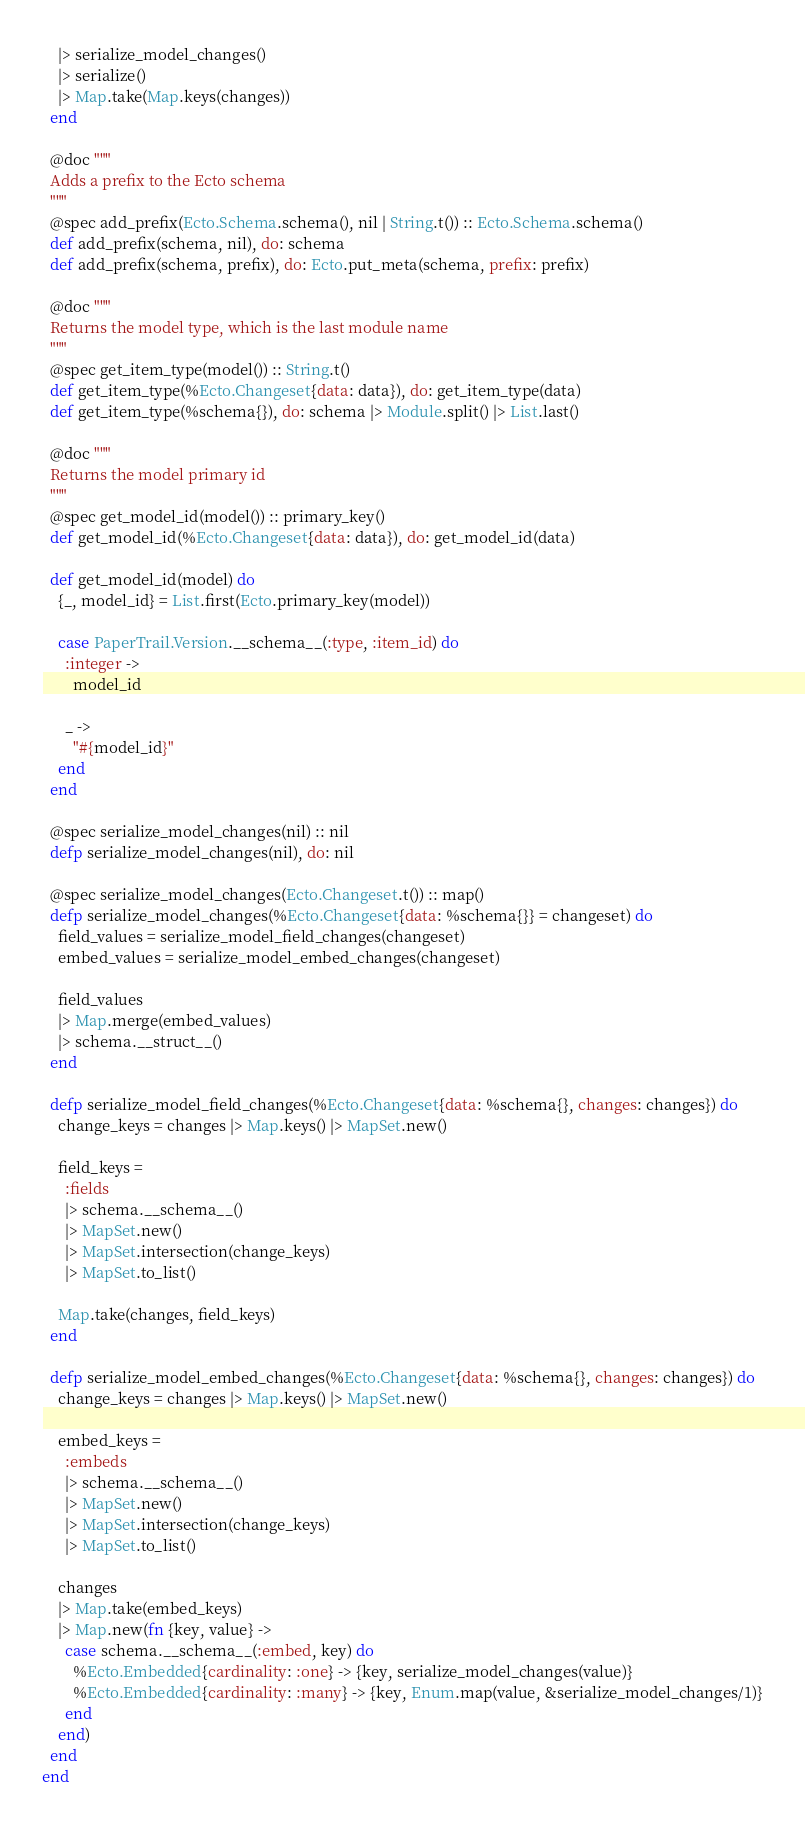Convert code to text. <code><loc_0><loc_0><loc_500><loc_500><_Elixir_>    |> serialize_model_changes()
    |> serialize()
    |> Map.take(Map.keys(changes))
  end

  @doc """
  Adds a prefix to the Ecto schema
  """
  @spec add_prefix(Ecto.Schema.schema(), nil | String.t()) :: Ecto.Schema.schema()
  def add_prefix(schema, nil), do: schema
  def add_prefix(schema, prefix), do: Ecto.put_meta(schema, prefix: prefix)

  @doc """
  Returns the model type, which is the last module name
  """
  @spec get_item_type(model()) :: String.t()
  def get_item_type(%Ecto.Changeset{data: data}), do: get_item_type(data)
  def get_item_type(%schema{}), do: schema |> Module.split() |> List.last()

  @doc """
  Returns the model primary id
  """
  @spec get_model_id(model()) :: primary_key()
  def get_model_id(%Ecto.Changeset{data: data}), do: get_model_id(data)

  def get_model_id(model) do
    {_, model_id} = List.first(Ecto.primary_key(model))

    case PaperTrail.Version.__schema__(:type, :item_id) do
      :integer ->
        model_id

      _ ->
        "#{model_id}"
    end
  end

  @spec serialize_model_changes(nil) :: nil
  defp serialize_model_changes(nil), do: nil

  @spec serialize_model_changes(Ecto.Changeset.t()) :: map()
  defp serialize_model_changes(%Ecto.Changeset{data: %schema{}} = changeset) do
    field_values = serialize_model_field_changes(changeset)
    embed_values = serialize_model_embed_changes(changeset)

    field_values
    |> Map.merge(embed_values)
    |> schema.__struct__()
  end

  defp serialize_model_field_changes(%Ecto.Changeset{data: %schema{}, changes: changes}) do
    change_keys = changes |> Map.keys() |> MapSet.new()

    field_keys =
      :fields
      |> schema.__schema__()
      |> MapSet.new()
      |> MapSet.intersection(change_keys)
      |> MapSet.to_list()

    Map.take(changes, field_keys)
  end

  defp serialize_model_embed_changes(%Ecto.Changeset{data: %schema{}, changes: changes}) do
    change_keys = changes |> Map.keys() |> MapSet.new()

    embed_keys =
      :embeds
      |> schema.__schema__()
      |> MapSet.new()
      |> MapSet.intersection(change_keys)
      |> MapSet.to_list()

    changes
    |> Map.take(embed_keys)
    |> Map.new(fn {key, value} ->
      case schema.__schema__(:embed, key) do
        %Ecto.Embedded{cardinality: :one} -> {key, serialize_model_changes(value)}
        %Ecto.Embedded{cardinality: :many} -> {key, Enum.map(value, &serialize_model_changes/1)}
      end
    end)
  end
end
</code> 